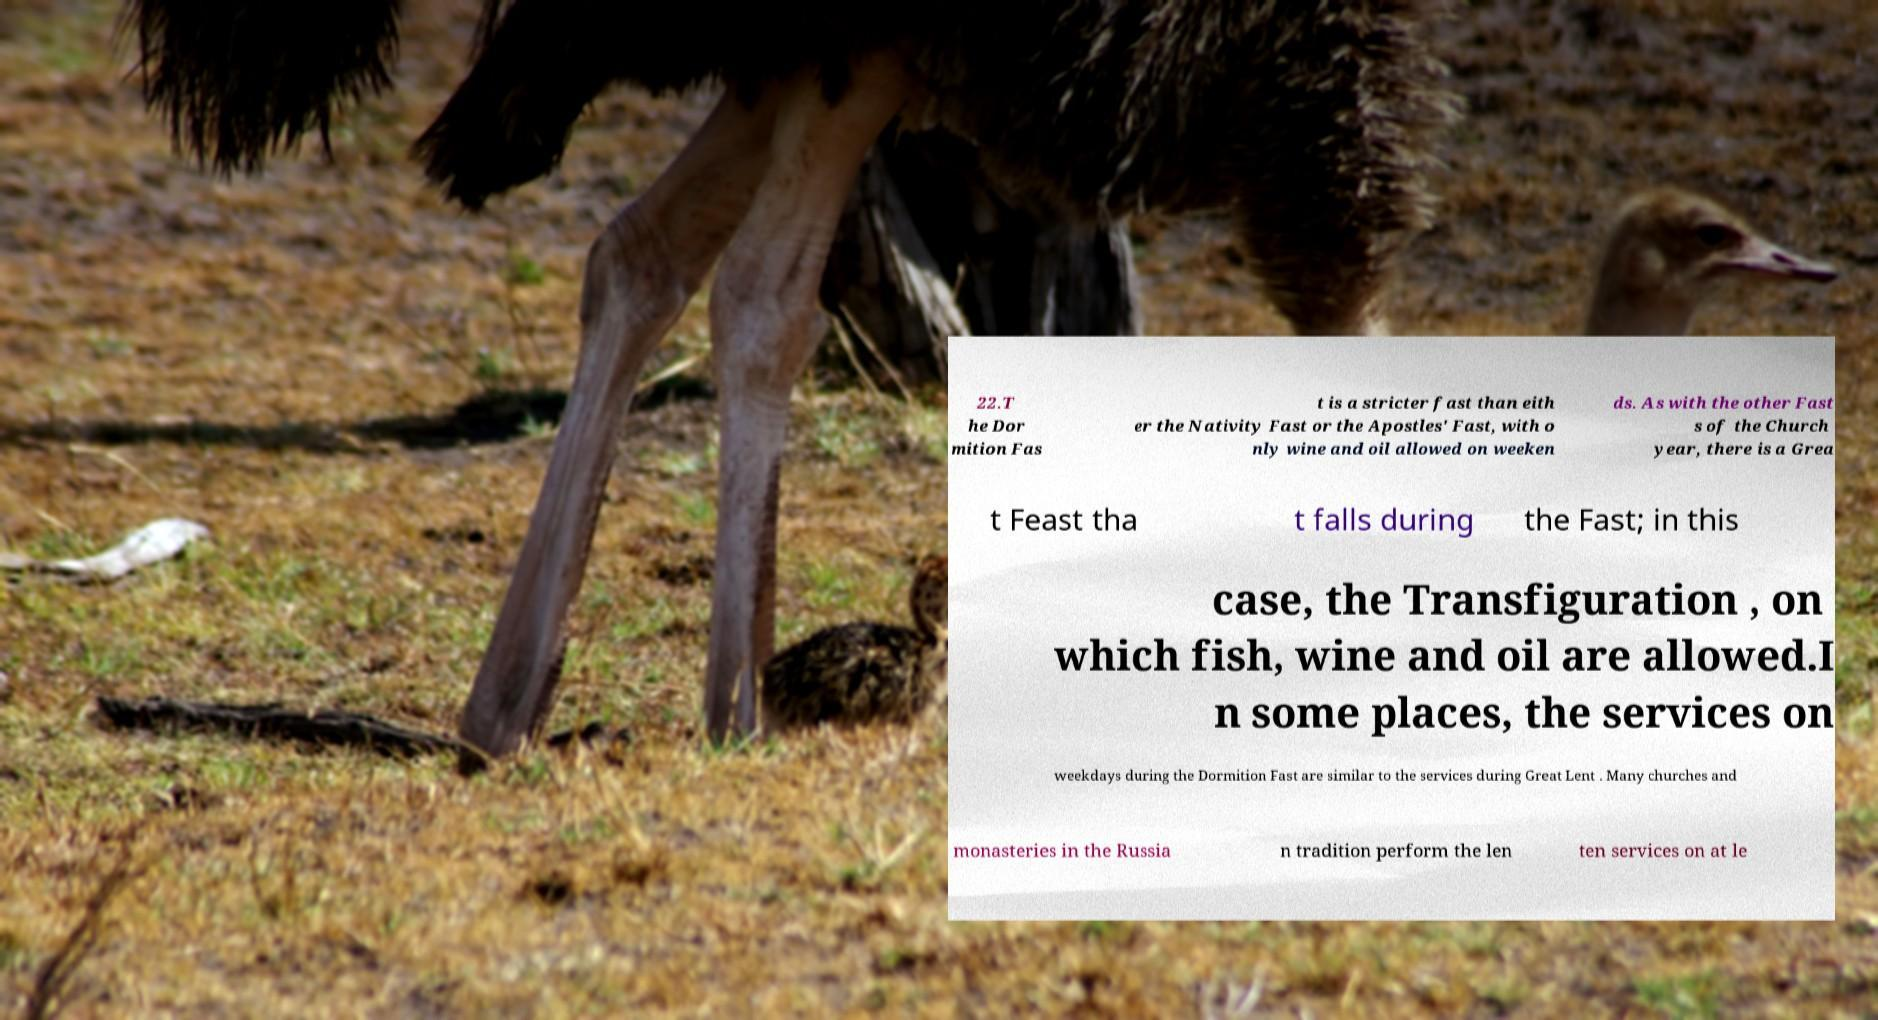Could you extract and type out the text from this image? 22.T he Dor mition Fas t is a stricter fast than eith er the Nativity Fast or the Apostles' Fast, with o nly wine and oil allowed on weeken ds. As with the other Fast s of the Church year, there is a Grea t Feast tha t falls during the Fast; in this case, the Transfiguration , on which fish, wine and oil are allowed.I n some places, the services on weekdays during the Dormition Fast are similar to the services during Great Lent . Many churches and monasteries in the Russia n tradition perform the len ten services on at le 